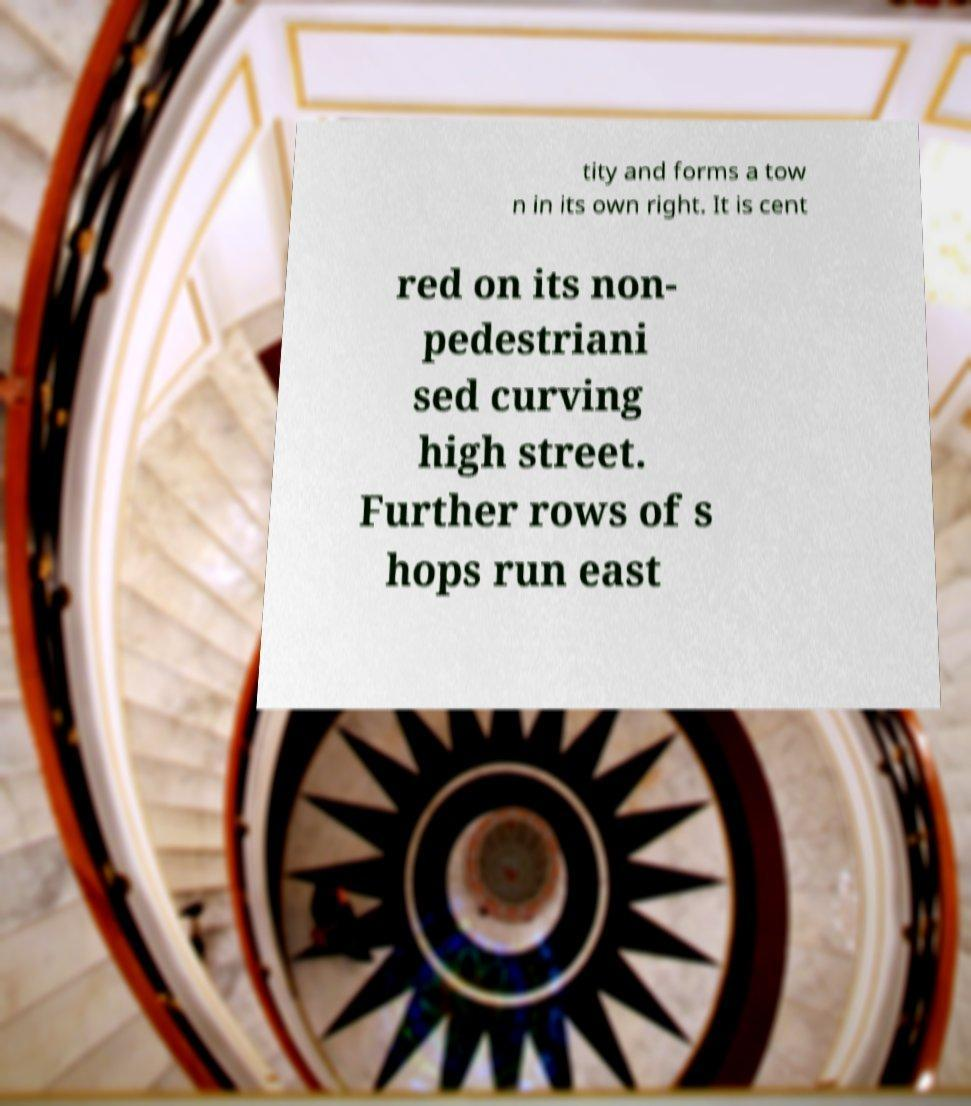I need the written content from this picture converted into text. Can you do that? tity and forms a tow n in its own right. It is cent red on its non- pedestriani sed curving high street. Further rows of s hops run east 